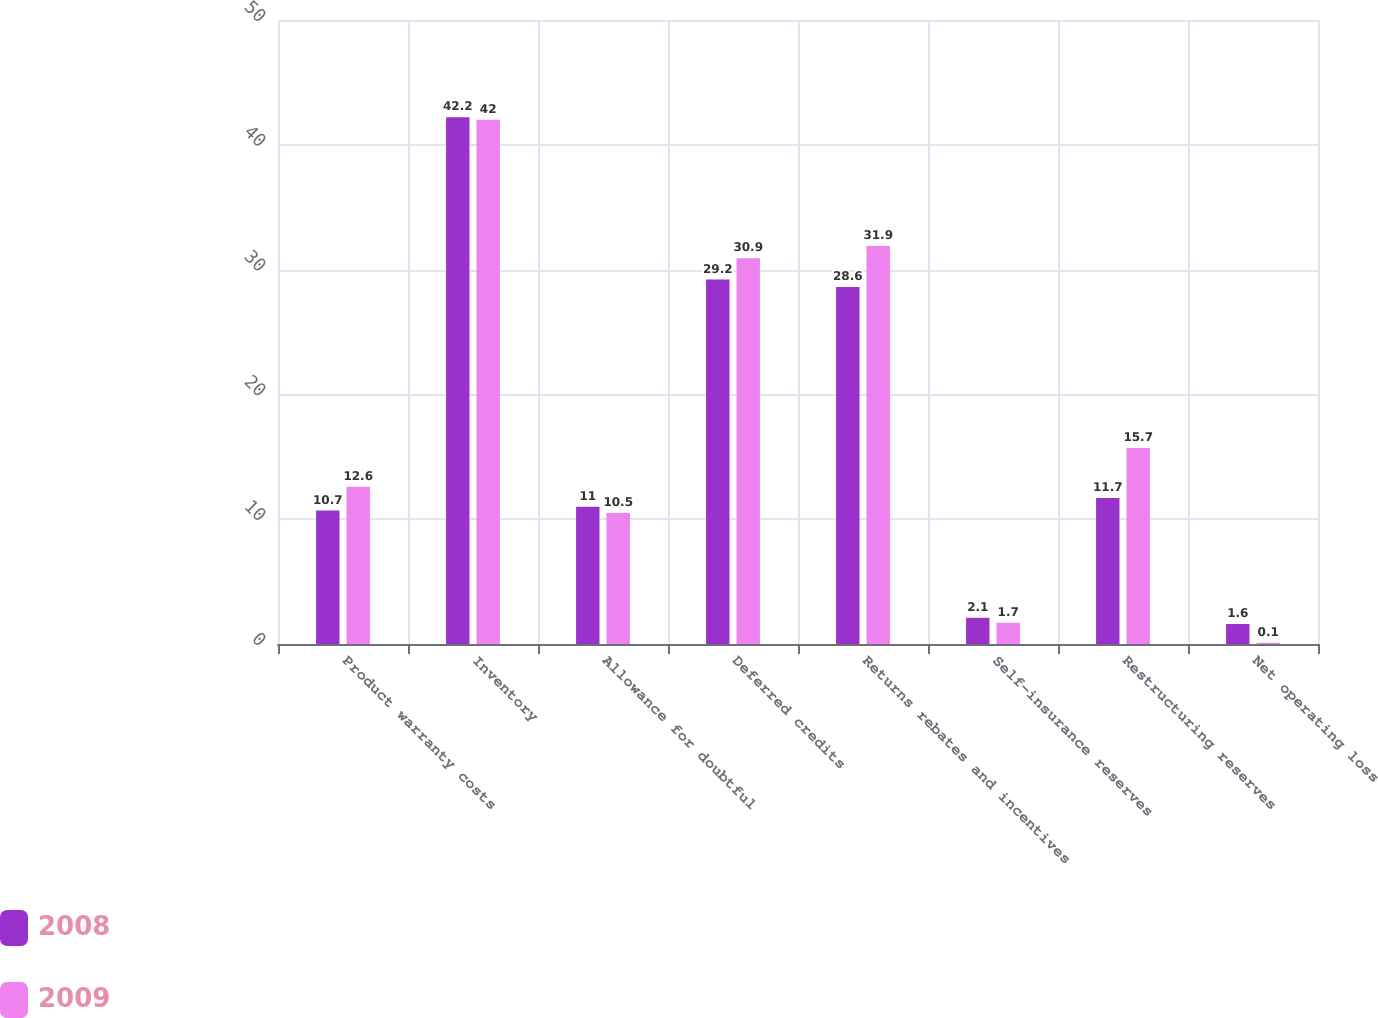Convert chart to OTSL. <chart><loc_0><loc_0><loc_500><loc_500><stacked_bar_chart><ecel><fcel>Product warranty costs<fcel>Inventory<fcel>Allowance for doubtful<fcel>Deferred credits<fcel>Returns rebates and incentives<fcel>Self-insurance reserves<fcel>Restructuring reserves<fcel>Net operating loss<nl><fcel>2008<fcel>10.7<fcel>42.2<fcel>11<fcel>29.2<fcel>28.6<fcel>2.1<fcel>11.7<fcel>1.6<nl><fcel>2009<fcel>12.6<fcel>42<fcel>10.5<fcel>30.9<fcel>31.9<fcel>1.7<fcel>15.7<fcel>0.1<nl></chart> 